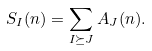Convert formula to latex. <formula><loc_0><loc_0><loc_500><loc_500>S _ { I } ( n ) = \sum _ { I \succeq J } A _ { J } ( n ) .</formula> 